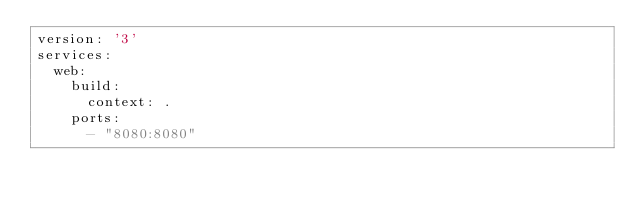Convert code to text. <code><loc_0><loc_0><loc_500><loc_500><_YAML_>version: '3'
services:
  web:
    build:
      context: .
    ports:
      - "8080:8080"
</code> 